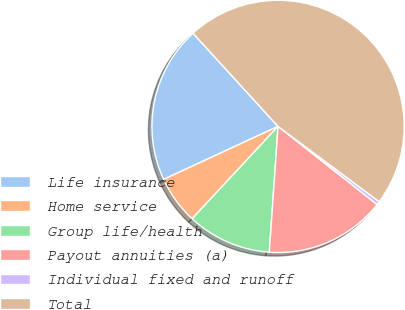Convert chart. <chart><loc_0><loc_0><loc_500><loc_500><pie_chart><fcel>Life insurance<fcel>Home service<fcel>Group life/health<fcel>Payout annuities (a)<fcel>Individual fixed and runoff<fcel>Total<nl><fcel>20.13%<fcel>6.17%<fcel>10.82%<fcel>15.48%<fcel>0.44%<fcel>46.96%<nl></chart> 